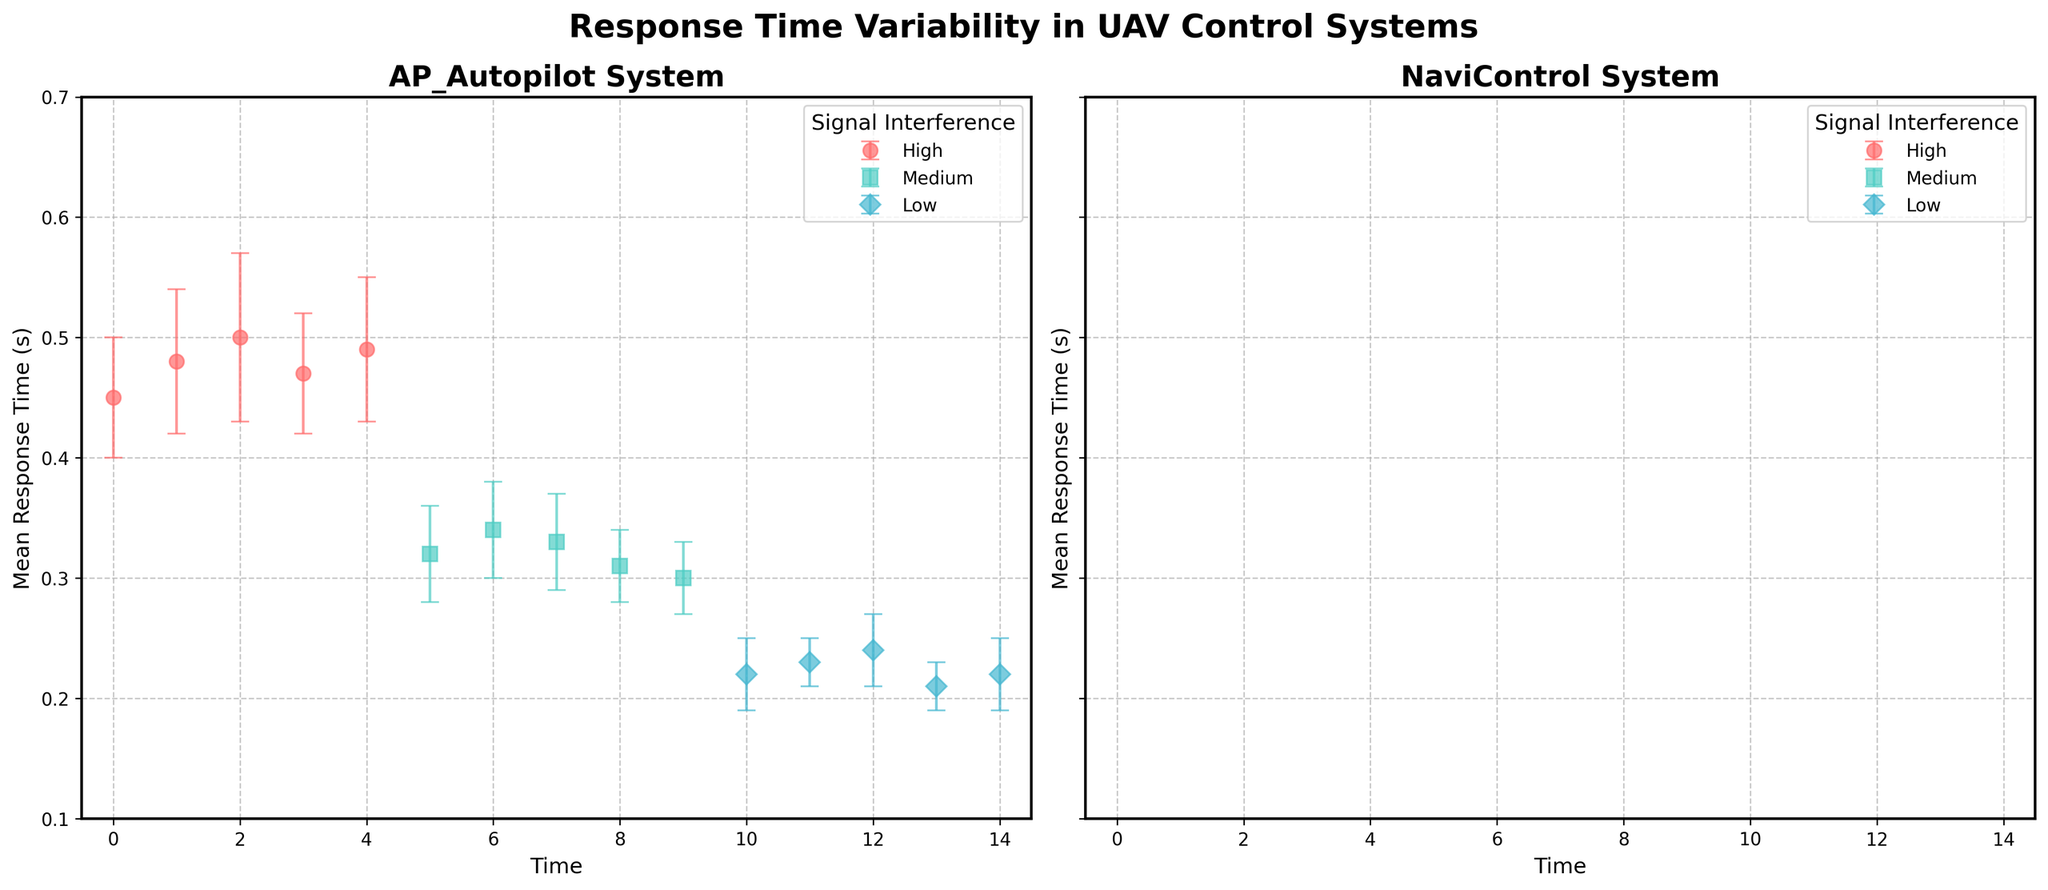What are the titles of the two subplots? The titles of the subplots are shown at the top of each subplot. The first subplot has the title "AP_Autopilot System" and the second subplot has the title "NaviControl System".
Answer: "AP_Autopilot System" and "NaviControl System" What is the y-axis label for each subplot? Both subplots share the same y-axis label, which is "Mean Response Time (s)". This can be seen on the left side of the plot area.
Answer: Mean Response Time (s) What is the lowest mean response time recorded for the Low interference level in the AP_Autopilot system? Look at the AP_Autopilot subplot, identify the points marked with color corresponding to Low interference (likely the third color in legend), and find the minimum value on the y-axis among those points.
Answer: 0.21 seconds How does the mean response time for the High interference level in the NaviControl system change over time? Look at the NaviControl subplot, identify the points for High interference level, then observe the trend of mean response times plotted on the y-axis against time on the x-axis. They start at 0.52, increase slightly, and then stabilize around 0.53 to 0.54.
Answer: It increases slightly and then stabilizes Which control system shows higher variability in response time under Medium interference levels? Compare the length of the error bars for Medium interference levels in both subplots. NaviControl's error bars for Medium interference are overall larger than AP_Autopilot's.
Answer: NaviControl System At what time point is the difference between the mean response times of AP_Autopilot and NaviControl the largest for High interference level? Compare the y-values of the High interference level points from both subplots across different time points. The largest difference is seen at time point 1 where AP_Autopilot is at 0.48 and NaviControl is at 0.55.
Answer: Time point 1 Which interference level in the NaviControl system has the smallest fluctuation in mean response time over the time period? Analyze the NaviControl subplot and look at the error bars for each interference level. The Low interference level shows the smallest error bars overall, indicating the least fluctuation.
Answer: Low What is the average mean response time for the AP_Autopilot system under Medium interference level? Calculate the average of the mean response times for Medium interference level from the AP_Autopilot subplot (0.32, 0.34, 0.33, 0.31, 0.30). The average is (0.32 + 0.34 + 0.33 + 0.31 + 0.30)/5.
Answer: 0.32 seconds Are there any points where the mean response time and its error bar overlap between Low and Medium interference levels in the AP_Autopilot system? Check for overlap by comparing the mean response times plus/minus their error bars for Low (0.22 ± 0.03, 0.23 ± 0.02, 0.24 ± 0.03, 0.21 ± 0.02, 0.22 ± 0.03) and Medium (0.32 ± 0.04, 0.34 ± 0.04, 0.33 ± 0.04, 0.31 ± 0.03, 0.30 ± 0.03) interference levels in the AP_Autopilot subplot. They do not overlap.
Answer: No 